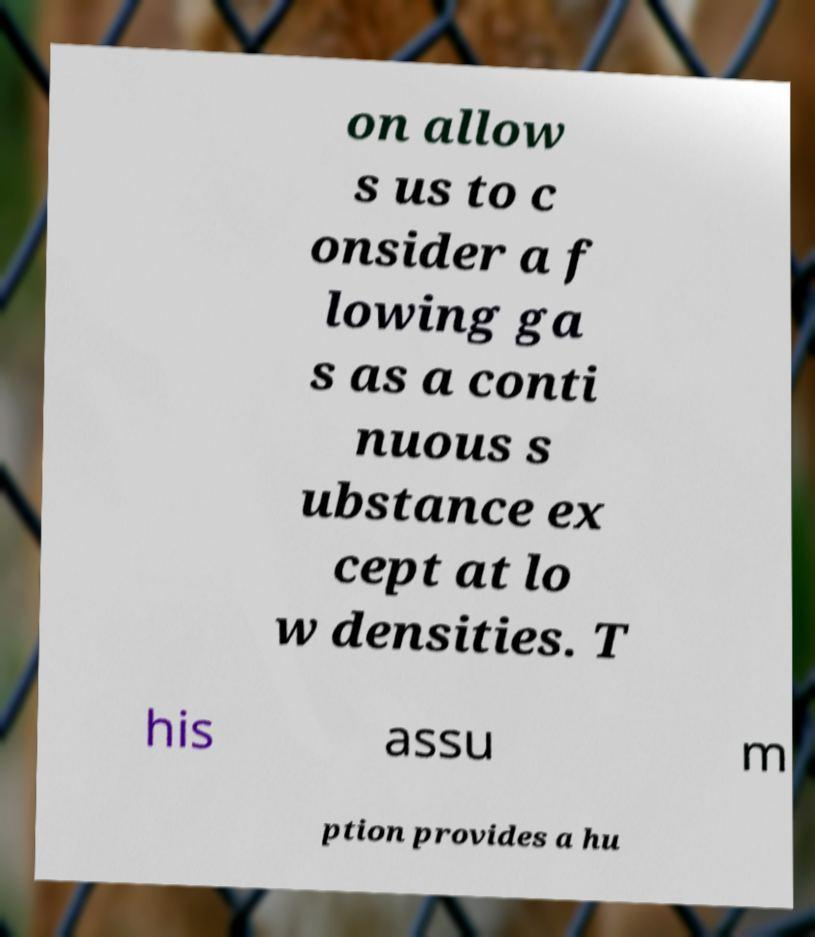I need the written content from this picture converted into text. Can you do that? on allow s us to c onsider a f lowing ga s as a conti nuous s ubstance ex cept at lo w densities. T his assu m ption provides a hu 